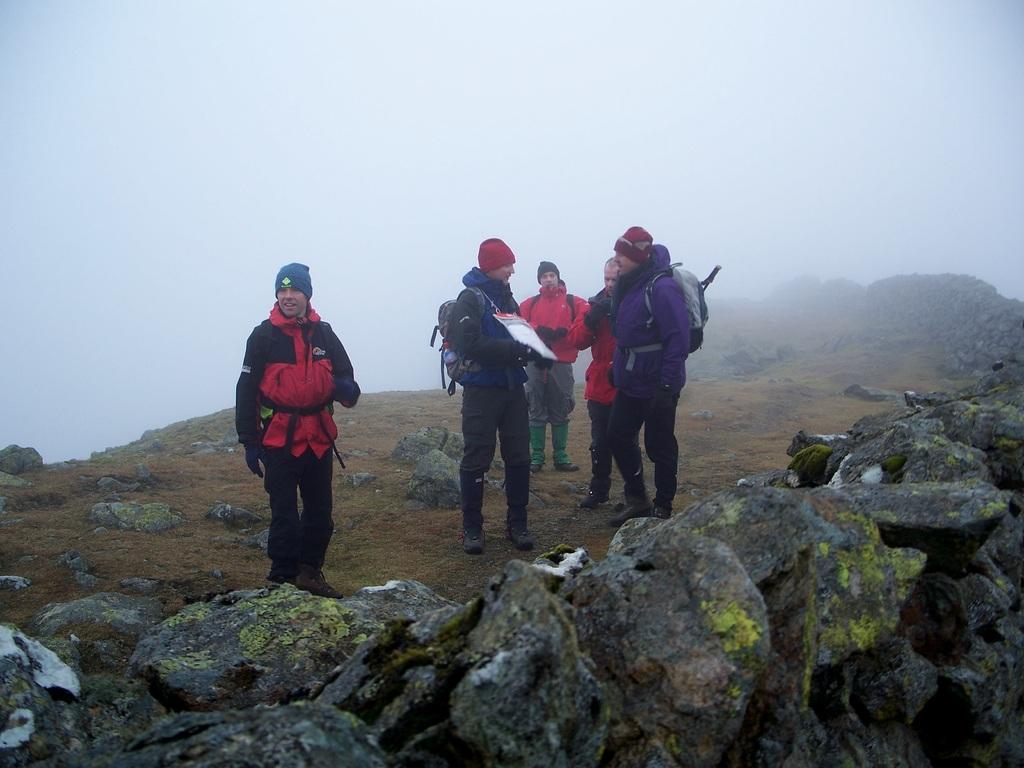Describe this image in one or two sentences. In this image we can see a few people standing and wearing backpacks, among them one person is holding an object, there are some rocks and also we can see the sky. 